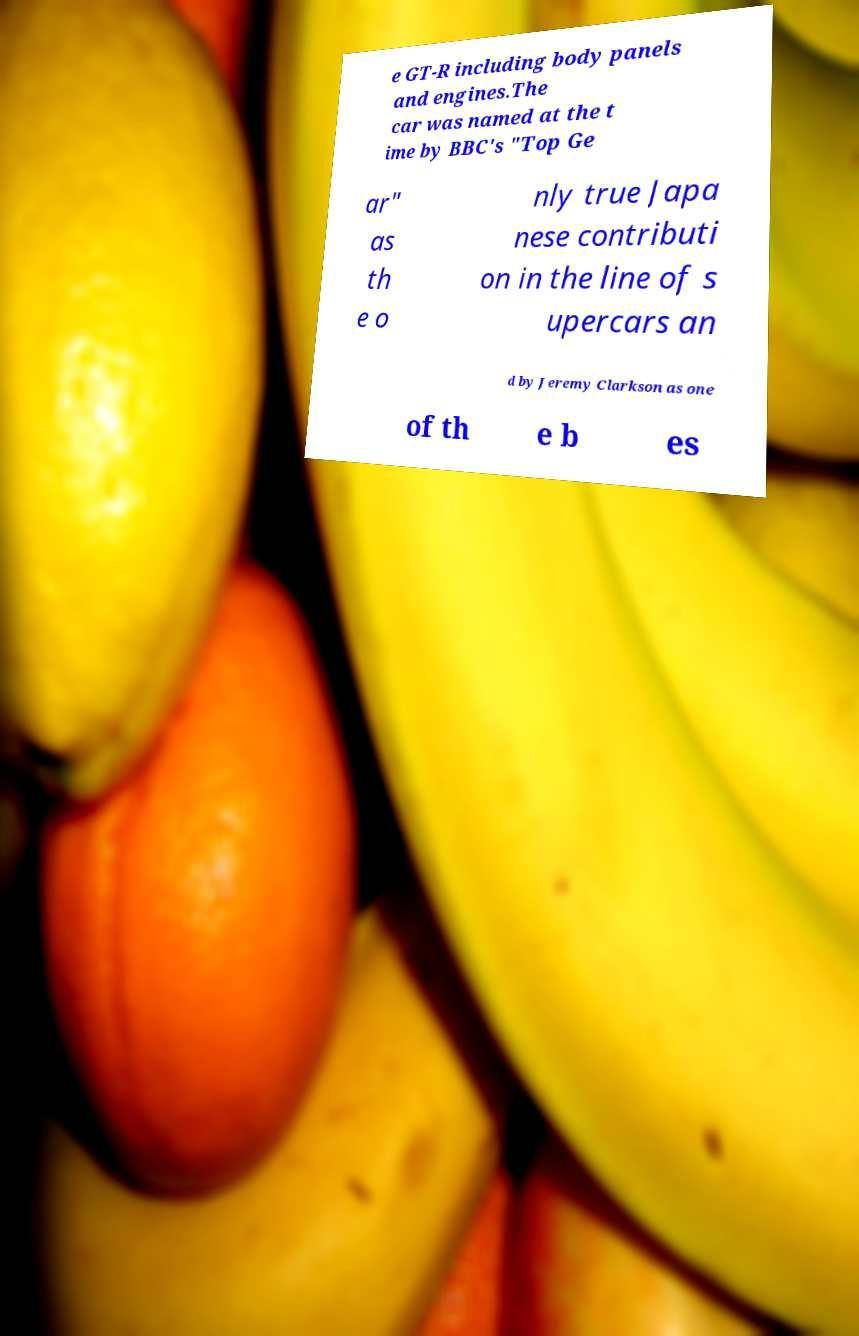Could you extract and type out the text from this image? e GT-R including body panels and engines.The car was named at the t ime by BBC's "Top Ge ar" as th e o nly true Japa nese contributi on in the line of s upercars an d by Jeremy Clarkson as one of th e b es 